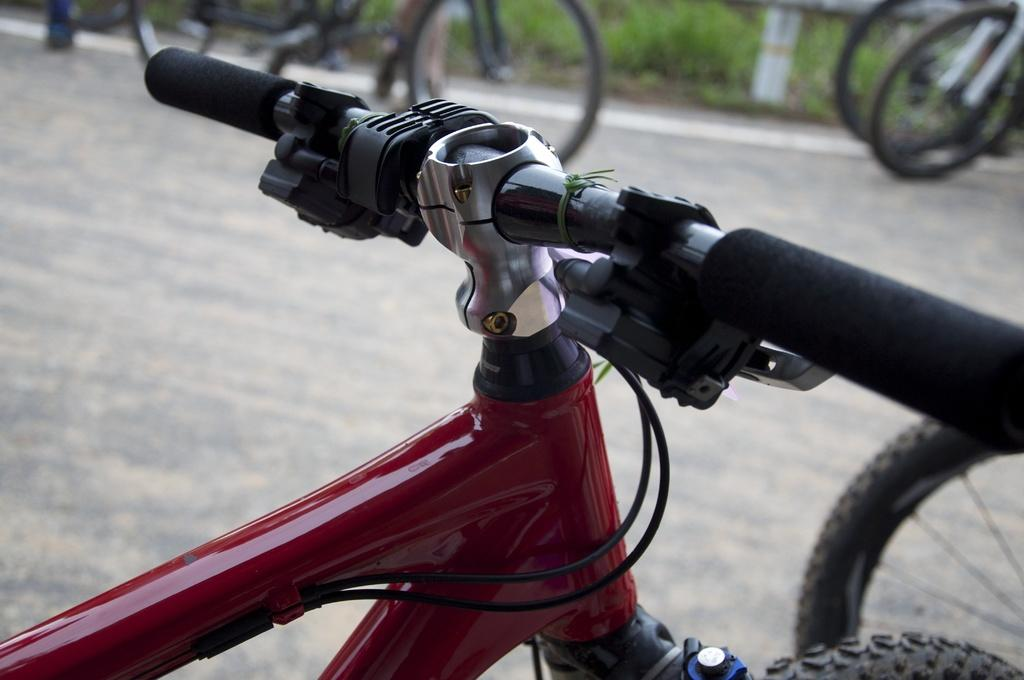What type of vehicles are in the image? There are bicycles in the image. Can you describe the color of the red and black bicycle? One of the bicycles is red and black in color. What can be seen in the background of the image? There are plants in the background of the image. What is the color of the plants? The plants are green in color. Is there a kitty starting a party with the bicycles in the image? There is no kitty or party present in the image; it features bicycles and plants in the background. 